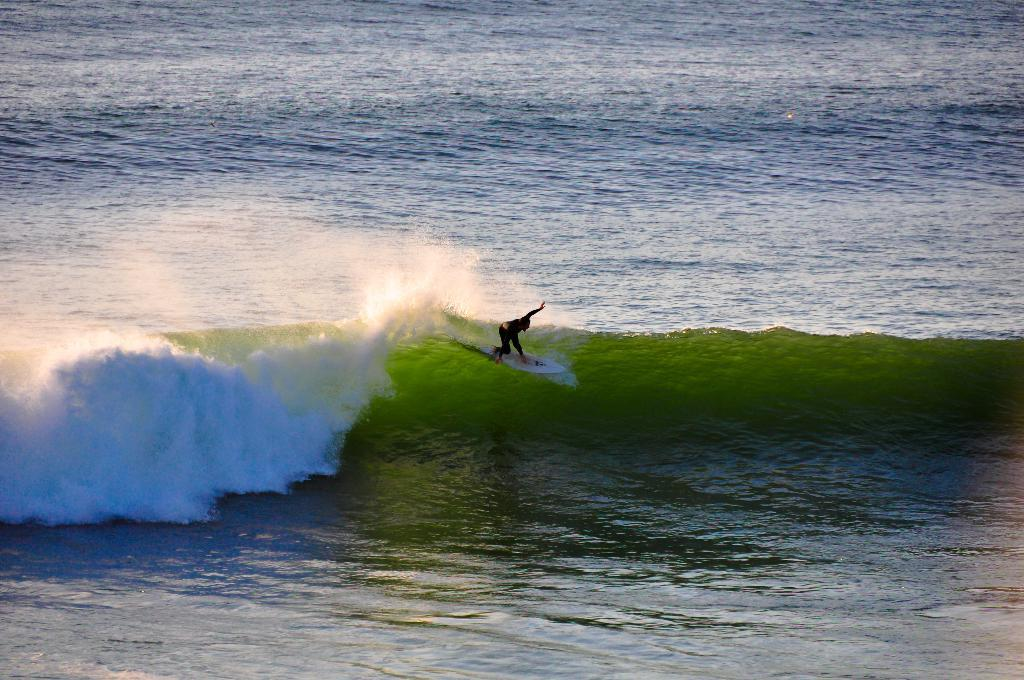What is the main subject of the image? There is a person in the image. What is the person doing in the image? The person is on a surfboard. What can be seen in the background of the image? There is water visible in the background of the image. What type of plants can be seen growing in the person's mind in the image? There is no indication of plants growing in the person's mind in the image, as the image focuses on the person surfing on a surfboard in water. 